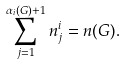Convert formula to latex. <formula><loc_0><loc_0><loc_500><loc_500>\sum _ { j = 1 } ^ { \alpha _ { i } ( G ) + 1 } n ^ { i } _ { j } = n ( G ) .</formula> 